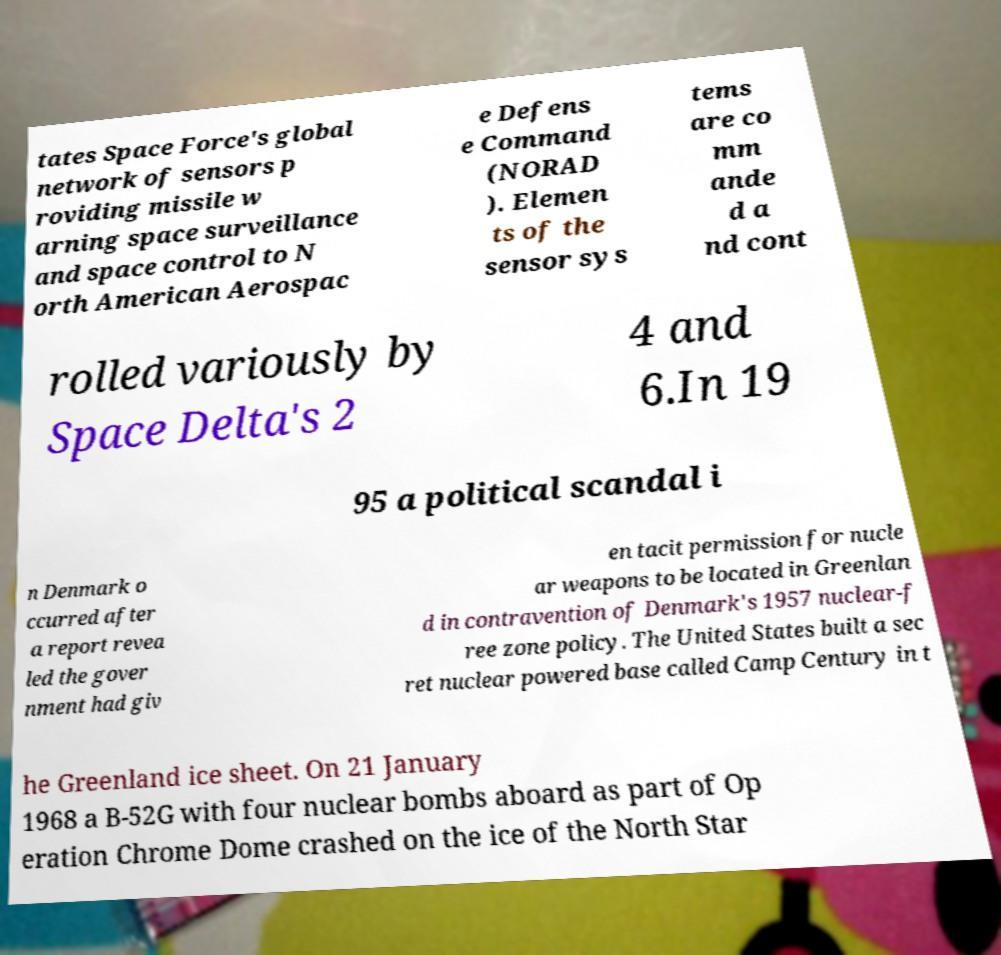I need the written content from this picture converted into text. Can you do that? tates Space Force's global network of sensors p roviding missile w arning space surveillance and space control to N orth American Aerospac e Defens e Command (NORAD ). Elemen ts of the sensor sys tems are co mm ande d a nd cont rolled variously by Space Delta's 2 4 and 6.In 19 95 a political scandal i n Denmark o ccurred after a report revea led the gover nment had giv en tacit permission for nucle ar weapons to be located in Greenlan d in contravention of Denmark's 1957 nuclear-f ree zone policy. The United States built a sec ret nuclear powered base called Camp Century in t he Greenland ice sheet. On 21 January 1968 a B-52G with four nuclear bombs aboard as part of Op eration Chrome Dome crashed on the ice of the North Star 